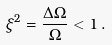<formula> <loc_0><loc_0><loc_500><loc_500>\xi ^ { 2 } = \frac { \Delta \Omega } { \Omega } < 1 \, .</formula> 